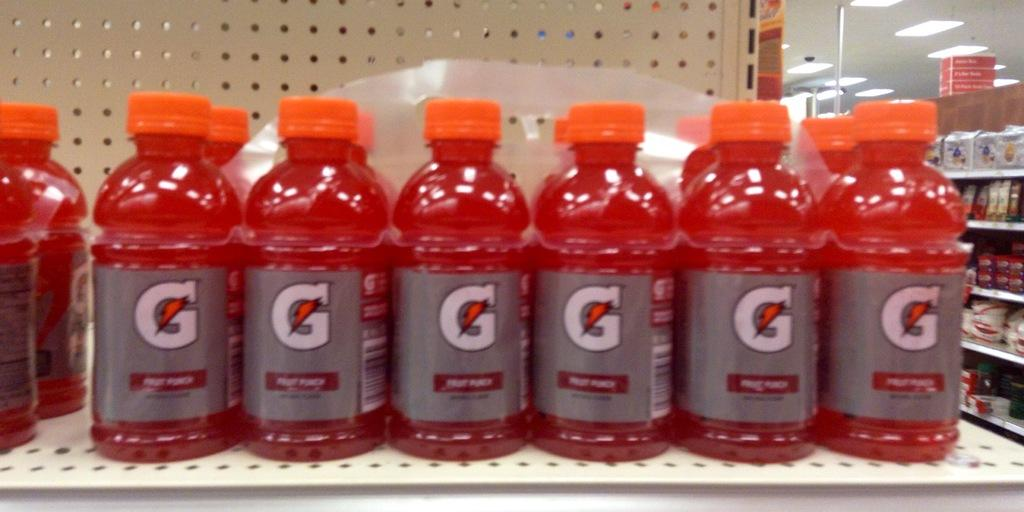<image>
Present a compact description of the photo's key features. Stack of Gatorade bottles on a store shelf with Fruit Punch flavor. 